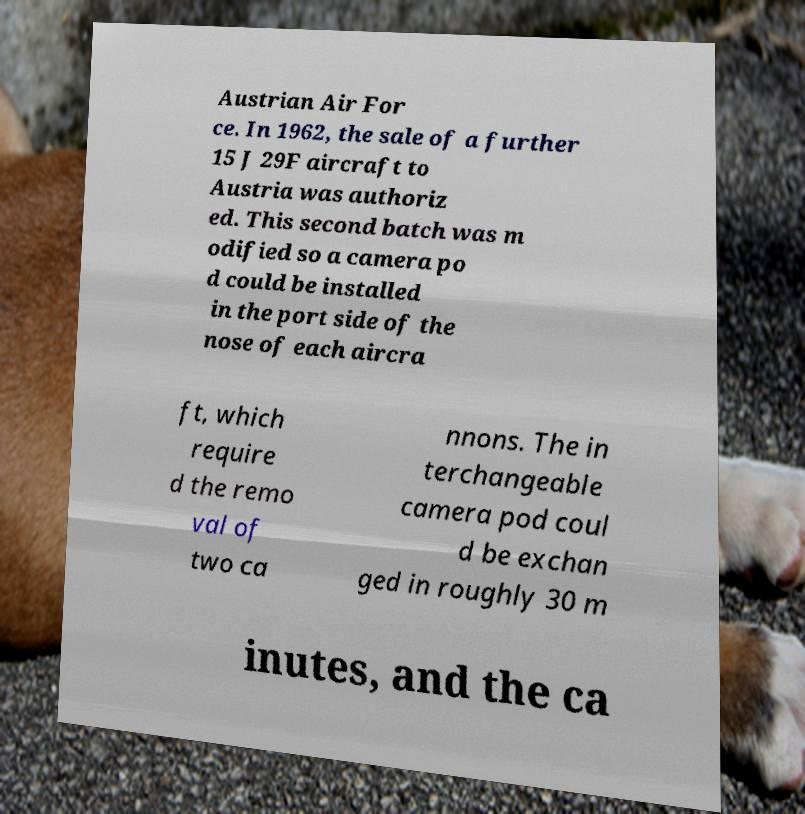There's text embedded in this image that I need extracted. Can you transcribe it verbatim? Austrian Air For ce. In 1962, the sale of a further 15 J 29F aircraft to Austria was authoriz ed. This second batch was m odified so a camera po d could be installed in the port side of the nose of each aircra ft, which require d the remo val of two ca nnons. The in terchangeable camera pod coul d be exchan ged in roughly 30 m inutes, and the ca 